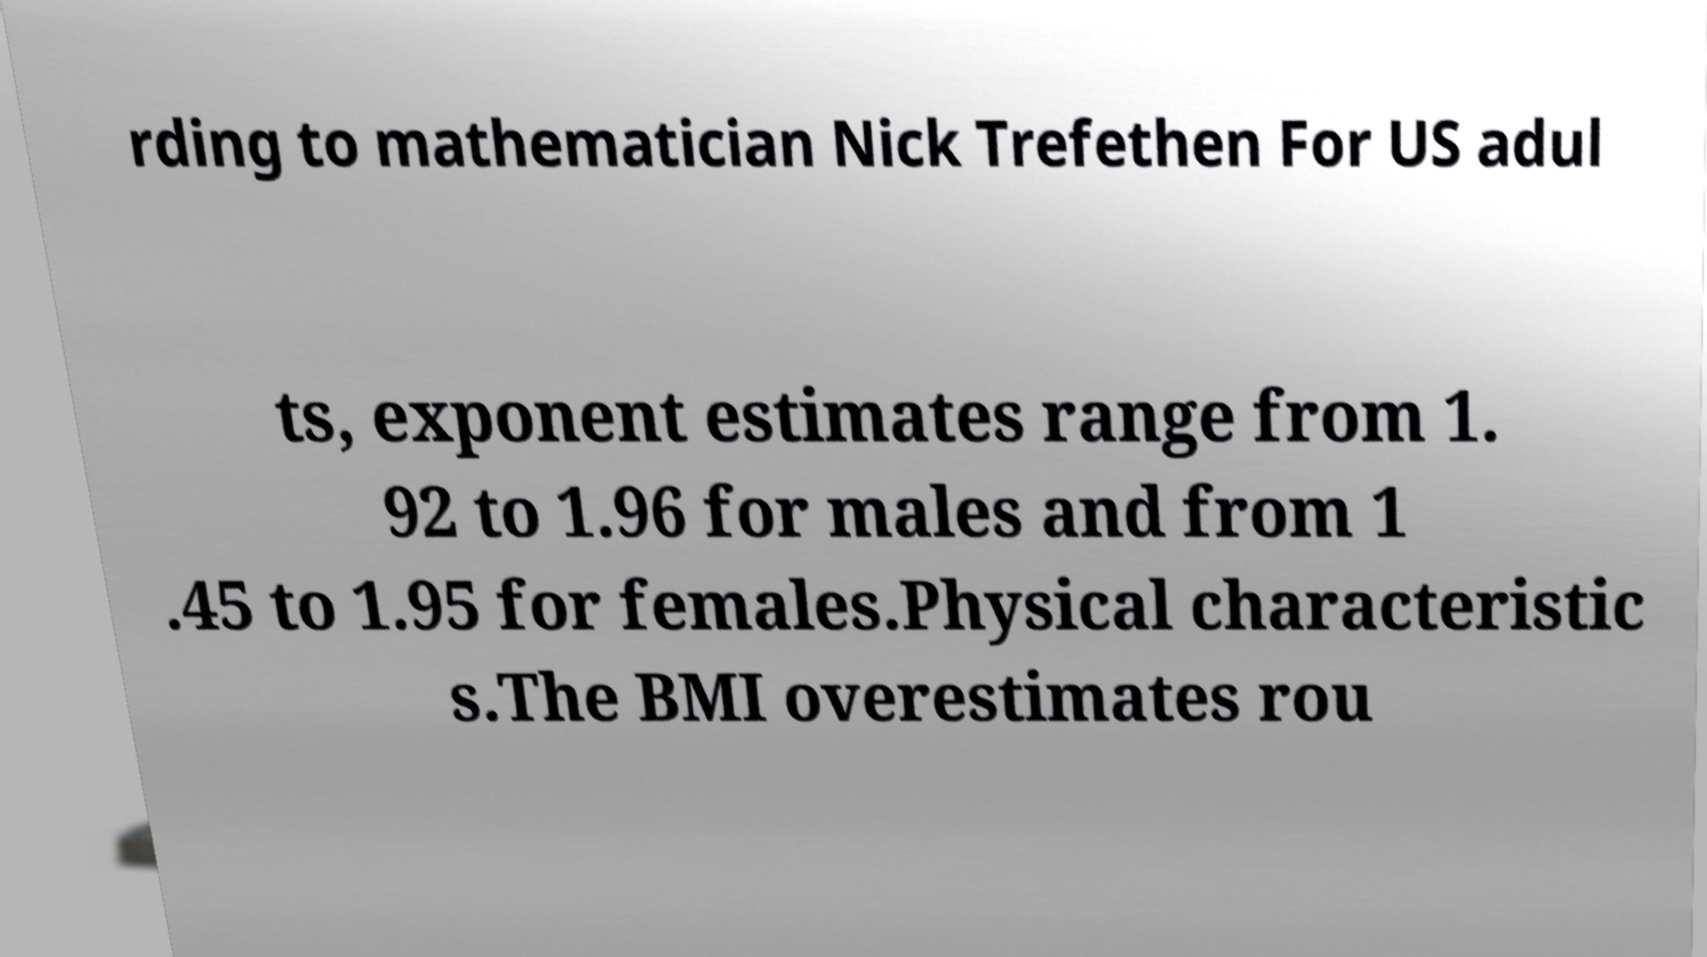Can you read and provide the text displayed in the image?This photo seems to have some interesting text. Can you extract and type it out for me? rding to mathematician Nick Trefethen For US adul ts, exponent estimates range from 1. 92 to 1.96 for males and from 1 .45 to 1.95 for females.Physical characteristic s.The BMI overestimates rou 